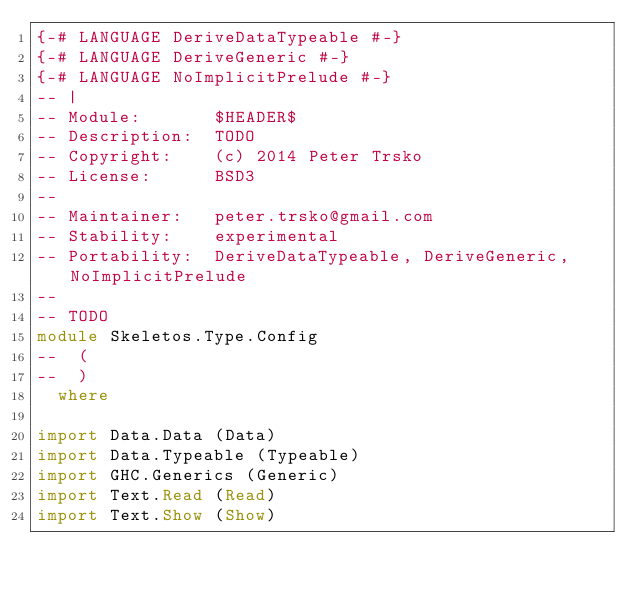Convert code to text. <code><loc_0><loc_0><loc_500><loc_500><_Haskell_>{-# LANGUAGE DeriveDataTypeable #-}
{-# LANGUAGE DeriveGeneric #-}
{-# LANGUAGE NoImplicitPrelude #-}
-- |
-- Module:       $HEADER$
-- Description:  TODO
-- Copyright:    (c) 2014 Peter Trsko
-- License:      BSD3
--
-- Maintainer:   peter.trsko@gmail.com
-- Stability:    experimental
-- Portability:  DeriveDataTypeable, DeriveGeneric, NoImplicitPrelude
--
-- TODO
module Skeletos.Type.Config
--  (
--  )
  where

import Data.Data (Data)
import Data.Typeable (Typeable)
import GHC.Generics (Generic)
import Text.Read (Read)
import Text.Show (Show)
</code> 